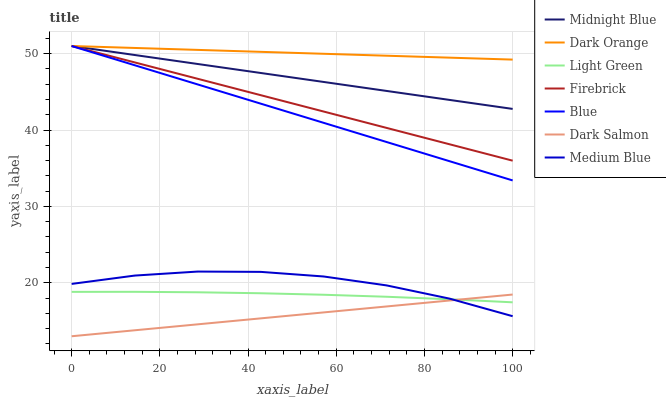Does Dark Salmon have the minimum area under the curve?
Answer yes or no. Yes. Does Dark Orange have the maximum area under the curve?
Answer yes or no. Yes. Does Midnight Blue have the minimum area under the curve?
Answer yes or no. No. Does Midnight Blue have the maximum area under the curve?
Answer yes or no. No. Is Blue the smoothest?
Answer yes or no. Yes. Is Medium Blue the roughest?
Answer yes or no. Yes. Is Dark Orange the smoothest?
Answer yes or no. No. Is Dark Orange the roughest?
Answer yes or no. No. Does Midnight Blue have the lowest value?
Answer yes or no. No. Does Firebrick have the highest value?
Answer yes or no. Yes. Does Medium Blue have the highest value?
Answer yes or no. No. Is Medium Blue less than Firebrick?
Answer yes or no. Yes. Is Firebrick greater than Medium Blue?
Answer yes or no. Yes. Does Medium Blue intersect Firebrick?
Answer yes or no. No. 